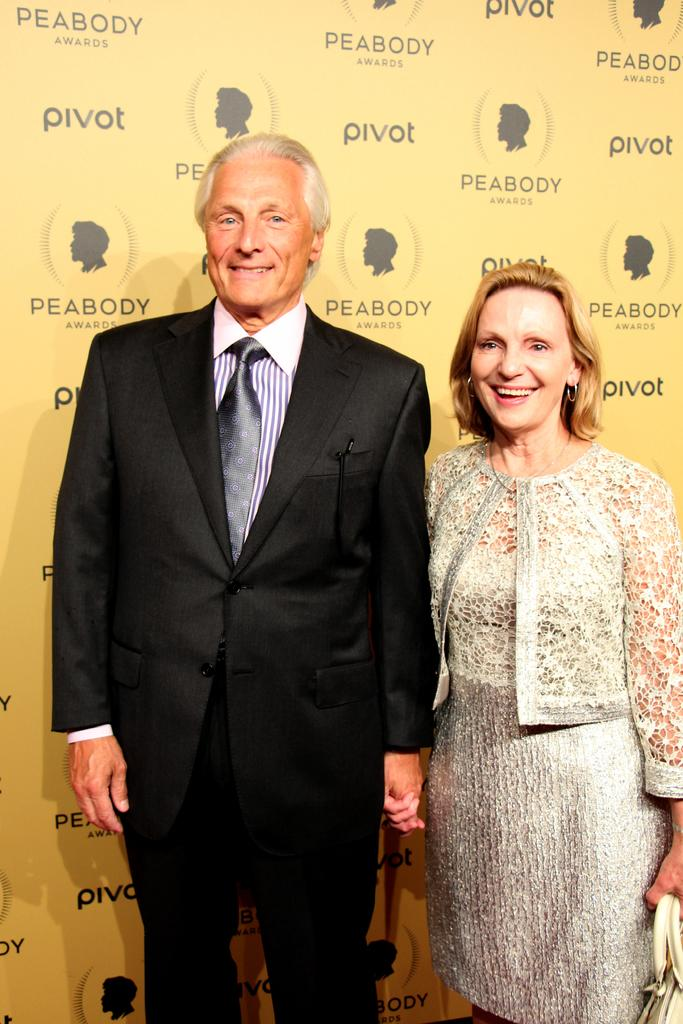How many people are in the image? There are two people in the image, a man and a woman. Where are the man and woman located in the image? The man and woman are standing in the foreground of the image. What can be seen in the background of the image? There is a poster in the background of the image. What month is depicted on the poster in the image? There is no information about the poster's content, so we cannot determine if a month is depicted. What type of metal is present in the image? There is no mention of any metal in the image, so we cannot determine if gold or zinc is present. 